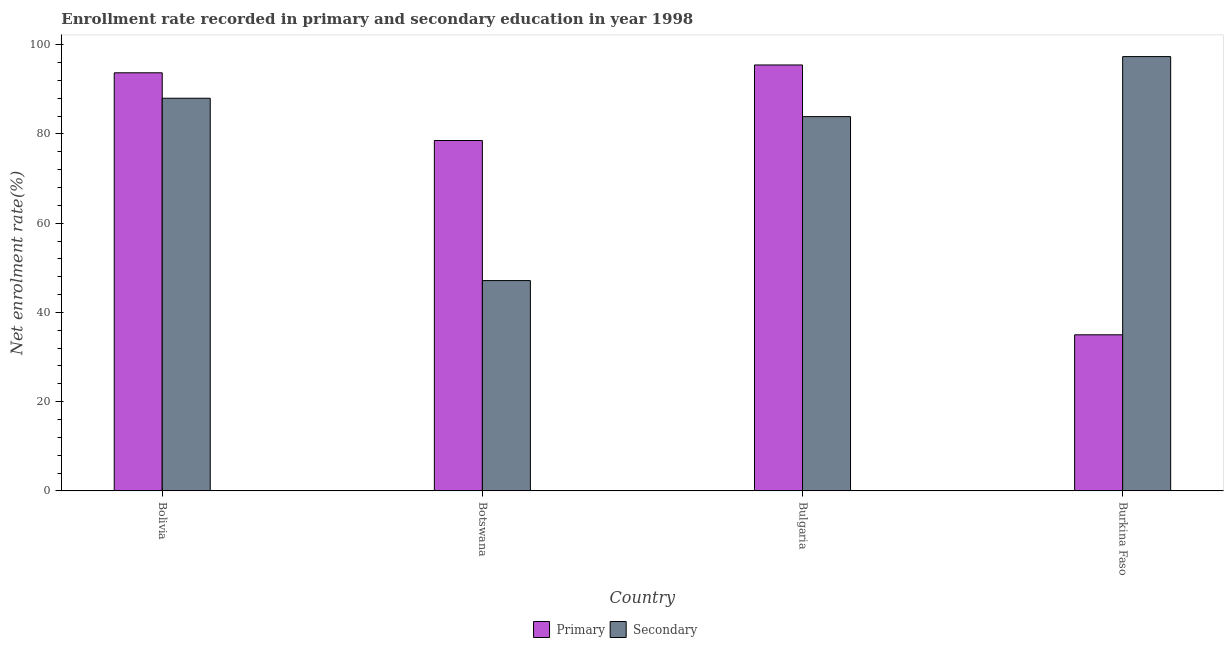How many groups of bars are there?
Keep it short and to the point. 4. What is the enrollment rate in primary education in Bolivia?
Make the answer very short. 93.69. Across all countries, what is the maximum enrollment rate in secondary education?
Offer a very short reply. 97.32. Across all countries, what is the minimum enrollment rate in secondary education?
Make the answer very short. 47.13. In which country was the enrollment rate in secondary education maximum?
Your answer should be very brief. Burkina Faso. In which country was the enrollment rate in primary education minimum?
Give a very brief answer. Burkina Faso. What is the total enrollment rate in secondary education in the graph?
Ensure brevity in your answer.  316.3. What is the difference between the enrollment rate in secondary education in Bolivia and that in Burkina Faso?
Give a very brief answer. -9.33. What is the difference between the enrollment rate in secondary education in Bulgaria and the enrollment rate in primary education in Botswana?
Ensure brevity in your answer.  5.35. What is the average enrollment rate in primary education per country?
Ensure brevity in your answer.  75.66. What is the difference between the enrollment rate in primary education and enrollment rate in secondary education in Bolivia?
Keep it short and to the point. 5.7. What is the ratio of the enrollment rate in primary education in Botswana to that in Bulgaria?
Offer a very short reply. 0.82. Is the difference between the enrollment rate in primary education in Bulgaria and Burkina Faso greater than the difference between the enrollment rate in secondary education in Bulgaria and Burkina Faso?
Provide a succinct answer. Yes. What is the difference between the highest and the second highest enrollment rate in secondary education?
Give a very brief answer. 9.33. What is the difference between the highest and the lowest enrollment rate in secondary education?
Provide a short and direct response. 50.19. In how many countries, is the enrollment rate in secondary education greater than the average enrollment rate in secondary education taken over all countries?
Provide a succinct answer. 3. Is the sum of the enrollment rate in secondary education in Bolivia and Botswana greater than the maximum enrollment rate in primary education across all countries?
Your answer should be very brief. Yes. What does the 2nd bar from the left in Burkina Faso represents?
Give a very brief answer. Secondary. What does the 2nd bar from the right in Burkina Faso represents?
Keep it short and to the point. Primary. Are all the bars in the graph horizontal?
Keep it short and to the point. No. How many countries are there in the graph?
Your answer should be very brief. 4. Are the values on the major ticks of Y-axis written in scientific E-notation?
Provide a succinct answer. No. Does the graph contain any zero values?
Your response must be concise. No. How many legend labels are there?
Give a very brief answer. 2. How are the legend labels stacked?
Your response must be concise. Horizontal. What is the title of the graph?
Ensure brevity in your answer.  Enrollment rate recorded in primary and secondary education in year 1998. What is the label or title of the X-axis?
Make the answer very short. Country. What is the label or title of the Y-axis?
Provide a short and direct response. Net enrolment rate(%). What is the Net enrolment rate(%) of Primary in Bolivia?
Make the answer very short. 93.69. What is the Net enrolment rate(%) of Secondary in Bolivia?
Offer a very short reply. 87.99. What is the Net enrolment rate(%) in Primary in Botswana?
Make the answer very short. 78.51. What is the Net enrolment rate(%) of Secondary in Botswana?
Provide a succinct answer. 47.13. What is the Net enrolment rate(%) in Primary in Bulgaria?
Provide a succinct answer. 95.44. What is the Net enrolment rate(%) in Secondary in Bulgaria?
Your response must be concise. 83.87. What is the Net enrolment rate(%) in Primary in Burkina Faso?
Ensure brevity in your answer.  34.98. What is the Net enrolment rate(%) in Secondary in Burkina Faso?
Ensure brevity in your answer.  97.32. Across all countries, what is the maximum Net enrolment rate(%) of Primary?
Your response must be concise. 95.44. Across all countries, what is the maximum Net enrolment rate(%) of Secondary?
Give a very brief answer. 97.32. Across all countries, what is the minimum Net enrolment rate(%) of Primary?
Your response must be concise. 34.98. Across all countries, what is the minimum Net enrolment rate(%) of Secondary?
Provide a short and direct response. 47.13. What is the total Net enrolment rate(%) of Primary in the graph?
Give a very brief answer. 302.63. What is the total Net enrolment rate(%) in Secondary in the graph?
Provide a succinct answer. 316.3. What is the difference between the Net enrolment rate(%) of Primary in Bolivia and that in Botswana?
Ensure brevity in your answer.  15.17. What is the difference between the Net enrolment rate(%) in Secondary in Bolivia and that in Botswana?
Give a very brief answer. 40.85. What is the difference between the Net enrolment rate(%) of Primary in Bolivia and that in Bulgaria?
Make the answer very short. -1.75. What is the difference between the Net enrolment rate(%) of Secondary in Bolivia and that in Bulgaria?
Ensure brevity in your answer.  4.12. What is the difference between the Net enrolment rate(%) of Primary in Bolivia and that in Burkina Faso?
Provide a short and direct response. 58.71. What is the difference between the Net enrolment rate(%) in Secondary in Bolivia and that in Burkina Faso?
Keep it short and to the point. -9.33. What is the difference between the Net enrolment rate(%) in Primary in Botswana and that in Bulgaria?
Offer a very short reply. -16.93. What is the difference between the Net enrolment rate(%) in Secondary in Botswana and that in Bulgaria?
Give a very brief answer. -36.74. What is the difference between the Net enrolment rate(%) in Primary in Botswana and that in Burkina Faso?
Offer a very short reply. 43.53. What is the difference between the Net enrolment rate(%) of Secondary in Botswana and that in Burkina Faso?
Offer a terse response. -50.19. What is the difference between the Net enrolment rate(%) of Primary in Bulgaria and that in Burkina Faso?
Make the answer very short. 60.46. What is the difference between the Net enrolment rate(%) of Secondary in Bulgaria and that in Burkina Faso?
Provide a succinct answer. -13.45. What is the difference between the Net enrolment rate(%) of Primary in Bolivia and the Net enrolment rate(%) of Secondary in Botswana?
Give a very brief answer. 46.56. What is the difference between the Net enrolment rate(%) in Primary in Bolivia and the Net enrolment rate(%) in Secondary in Bulgaria?
Offer a terse response. 9.82. What is the difference between the Net enrolment rate(%) of Primary in Bolivia and the Net enrolment rate(%) of Secondary in Burkina Faso?
Offer a terse response. -3.63. What is the difference between the Net enrolment rate(%) in Primary in Botswana and the Net enrolment rate(%) in Secondary in Bulgaria?
Your answer should be compact. -5.35. What is the difference between the Net enrolment rate(%) in Primary in Botswana and the Net enrolment rate(%) in Secondary in Burkina Faso?
Your response must be concise. -18.8. What is the difference between the Net enrolment rate(%) in Primary in Bulgaria and the Net enrolment rate(%) in Secondary in Burkina Faso?
Make the answer very short. -1.88. What is the average Net enrolment rate(%) in Primary per country?
Your answer should be very brief. 75.66. What is the average Net enrolment rate(%) in Secondary per country?
Offer a terse response. 79.08. What is the difference between the Net enrolment rate(%) of Primary and Net enrolment rate(%) of Secondary in Bolivia?
Offer a terse response. 5.7. What is the difference between the Net enrolment rate(%) in Primary and Net enrolment rate(%) in Secondary in Botswana?
Offer a terse response. 31.38. What is the difference between the Net enrolment rate(%) of Primary and Net enrolment rate(%) of Secondary in Bulgaria?
Offer a very short reply. 11.57. What is the difference between the Net enrolment rate(%) of Primary and Net enrolment rate(%) of Secondary in Burkina Faso?
Give a very brief answer. -62.34. What is the ratio of the Net enrolment rate(%) in Primary in Bolivia to that in Botswana?
Provide a succinct answer. 1.19. What is the ratio of the Net enrolment rate(%) in Secondary in Bolivia to that in Botswana?
Ensure brevity in your answer.  1.87. What is the ratio of the Net enrolment rate(%) of Primary in Bolivia to that in Bulgaria?
Your response must be concise. 0.98. What is the ratio of the Net enrolment rate(%) of Secondary in Bolivia to that in Bulgaria?
Offer a very short reply. 1.05. What is the ratio of the Net enrolment rate(%) of Primary in Bolivia to that in Burkina Faso?
Offer a very short reply. 2.68. What is the ratio of the Net enrolment rate(%) in Secondary in Bolivia to that in Burkina Faso?
Provide a short and direct response. 0.9. What is the ratio of the Net enrolment rate(%) of Primary in Botswana to that in Bulgaria?
Your response must be concise. 0.82. What is the ratio of the Net enrolment rate(%) of Secondary in Botswana to that in Bulgaria?
Provide a succinct answer. 0.56. What is the ratio of the Net enrolment rate(%) in Primary in Botswana to that in Burkina Faso?
Give a very brief answer. 2.24. What is the ratio of the Net enrolment rate(%) in Secondary in Botswana to that in Burkina Faso?
Your answer should be compact. 0.48. What is the ratio of the Net enrolment rate(%) of Primary in Bulgaria to that in Burkina Faso?
Offer a terse response. 2.73. What is the ratio of the Net enrolment rate(%) of Secondary in Bulgaria to that in Burkina Faso?
Provide a succinct answer. 0.86. What is the difference between the highest and the second highest Net enrolment rate(%) of Primary?
Your answer should be compact. 1.75. What is the difference between the highest and the second highest Net enrolment rate(%) in Secondary?
Your response must be concise. 9.33. What is the difference between the highest and the lowest Net enrolment rate(%) of Primary?
Provide a succinct answer. 60.46. What is the difference between the highest and the lowest Net enrolment rate(%) in Secondary?
Offer a terse response. 50.19. 